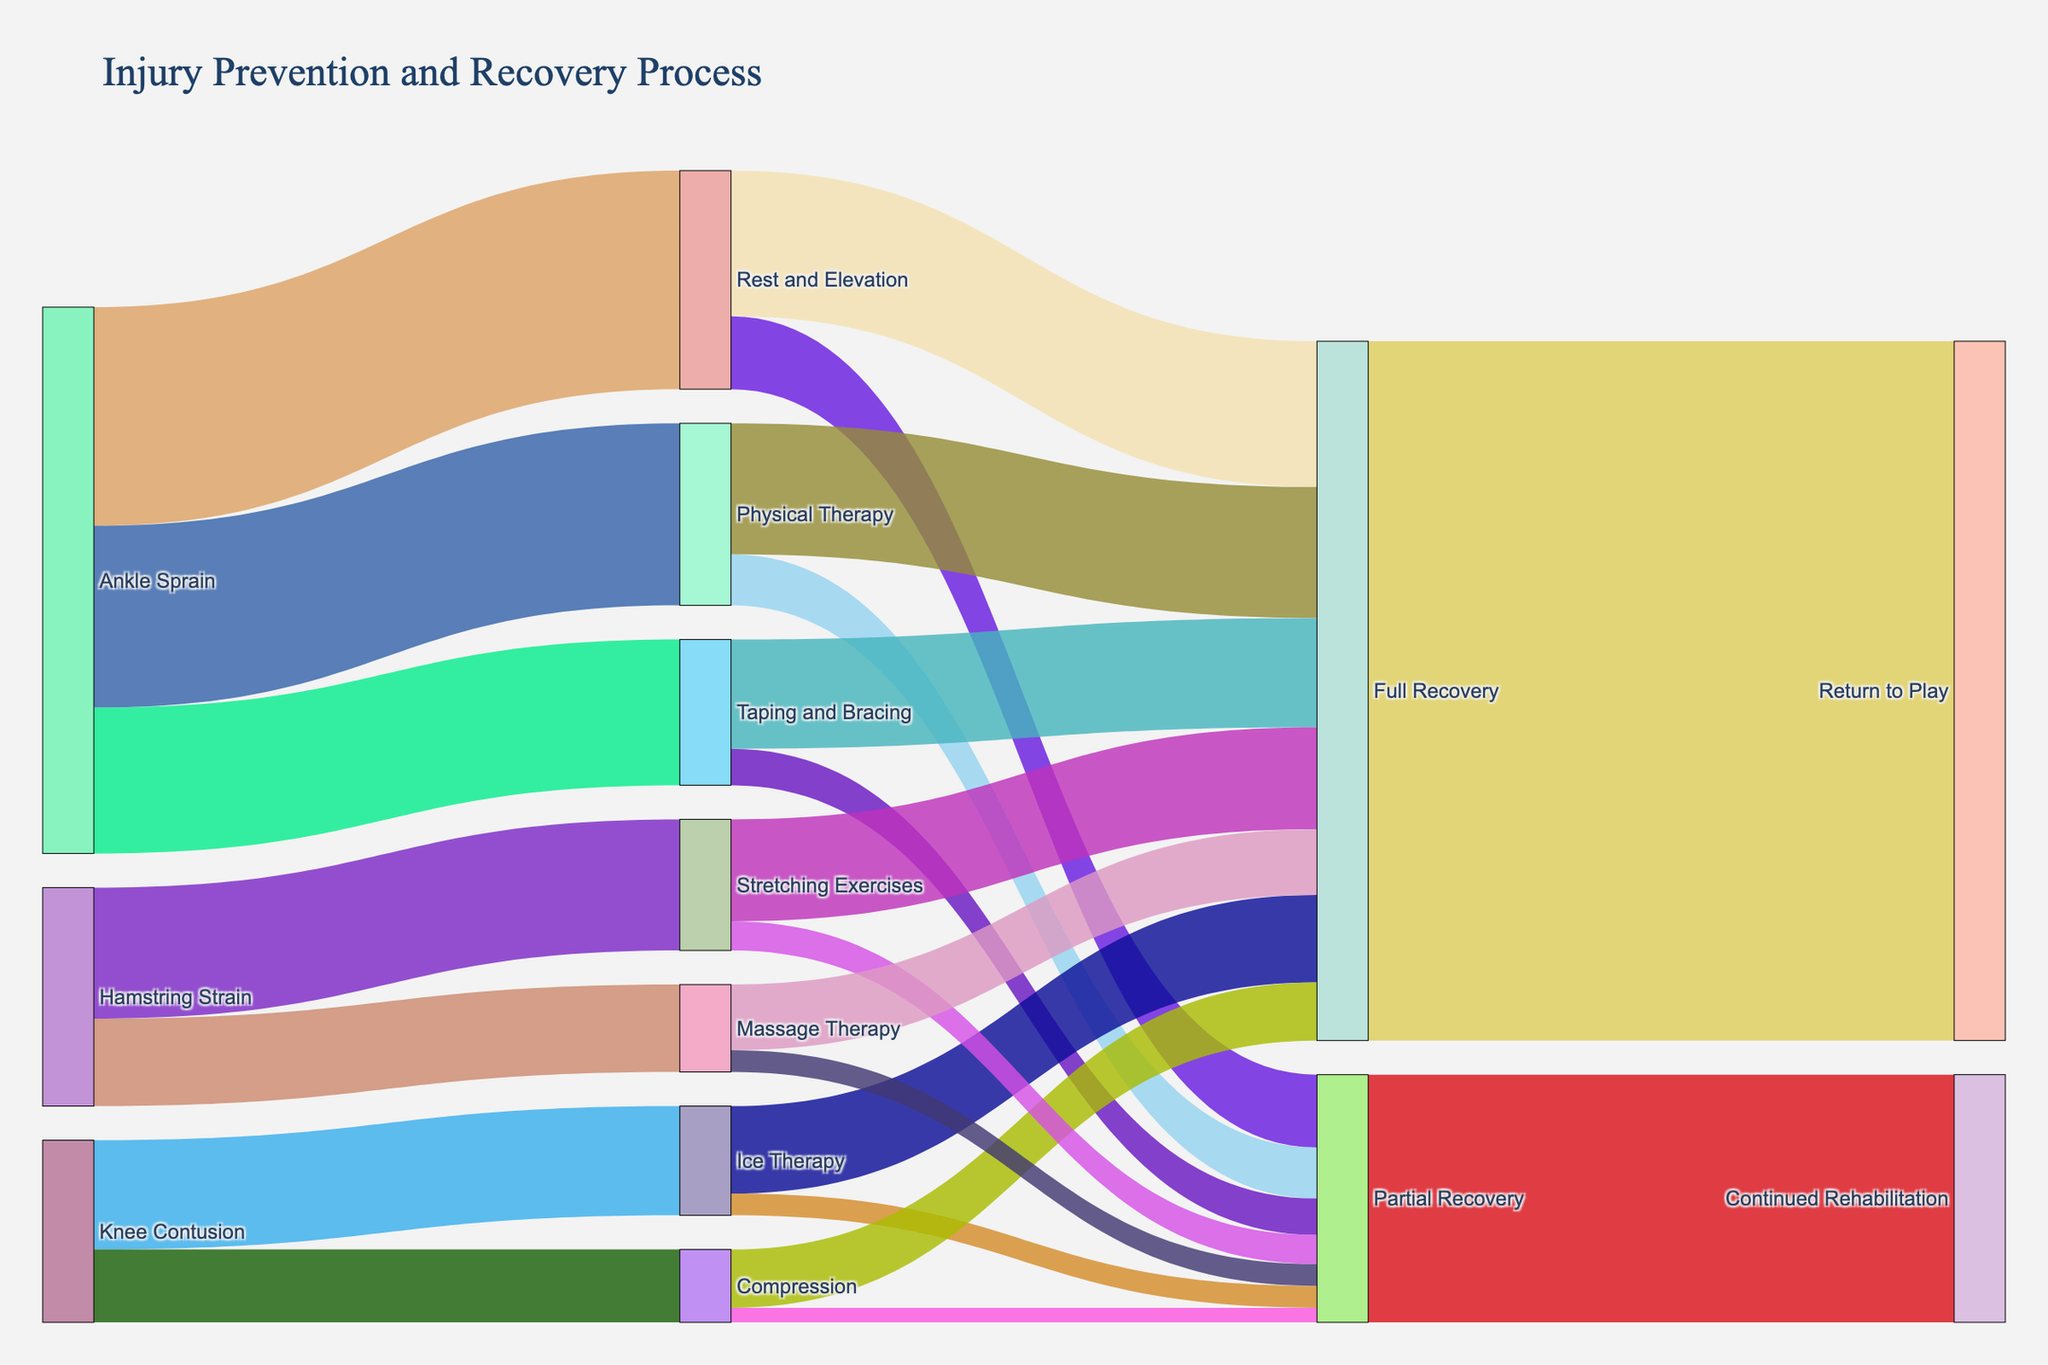What's the source of most initial injuries? The Sankey Diagram shows that the largest number of initial injury occurrences are from 'Ankle Sprain' with a total value of 75 (30 for Rest and Elevation, 25 for Physical Therapy, and 20 for Taping and Bracing).
Answer: Ankle Sprain What is the least effective treatment in terms of full recovery? Look at the full recovery flow values for each treatment. 'Compression' has the smallest full recovery value with only 8.
Answer: Compression How many total recovery cases lead to a return to play? Sum the values flowing into 'Full Recovery' (20 from Rest and Elevation, 18 from Physical Therapy, 15 from Taping and Bracing, 12 from Ice Therapy, 8 from Compression, 14 from Stretching Exercises, 9 from Massage Therapy). The total is 96 and all flow into 'Return to Play'.
Answer: 96 Which treatment method results in the highest number of partial recoveries? Compare the partial recovery values for each treatment method. 'Physical Therapy' has the highest partial recovery value with 7.
Answer: Physical Therapy How many injury cases require continued rehabilitation? Sum the values flowing into 'Partial Recovery' (10 from Rest and Elevation, 7 from Physical Therapy, 5 from Taping and Bracing, 3 from Ice Therapy, 2 from Compression, 4 from Stretching Exercises, 3 from Massage Therapy). The total is 34, all of which flow into 'Continued Rehabilitation'.
Answer: 34 Which is more common after an Ankle Sprain: Physical Therapy or Taping and Bracing? Compare the values for Ankle Sprain leading to Physical Therapy and Taping and Bracing. Physical Therapy has a higher value of 25 compared to Taping and Bracing's 20.
Answer: Physical Therapy Are there more full recovery or partial recovery cases ending up in return to play? The diagram shows all full recovery cases (96) flow into 'Return to Play' while all partial recovery cases (34) flow into 'Continued Rehabilitation'. Hence, full recoveries are greater.
Answer: Full Recovery Which initial injury has the smallest number of recovery cases? Compare the initial injury values. 'Knee Contusion' leads to 25 cases (15 Ice Therapy, 10 Compression), which is the smallest number among the given categories.
Answer: Knee Contusion 